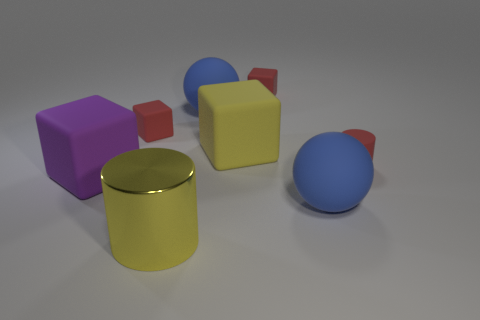Subtract all purple cubes. How many cubes are left? 3 Add 1 purple cubes. How many objects exist? 9 Add 2 small red shiny cylinders. How many small red shiny cylinders exist? 2 Subtract 0 cyan spheres. How many objects are left? 8 Subtract all cylinders. How many objects are left? 6 Subtract 1 balls. How many balls are left? 1 Subtract all brown cylinders. Subtract all green balls. How many cylinders are left? 2 Subtract all green spheres. How many green cylinders are left? 0 Subtract all tiny red rubber balls. Subtract all tiny red objects. How many objects are left? 5 Add 8 big yellow matte things. How many big yellow matte things are left? 9 